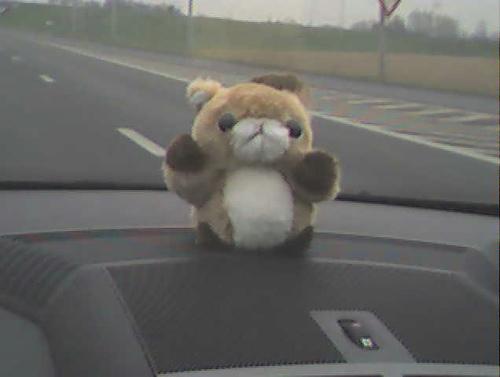Where is the toy located in the car?
Answer briefly. Dashboard. Does this owner have a soft side?
Short answer required. Yes. What animal does the plush appear to be?
Answer briefly. Bear. 